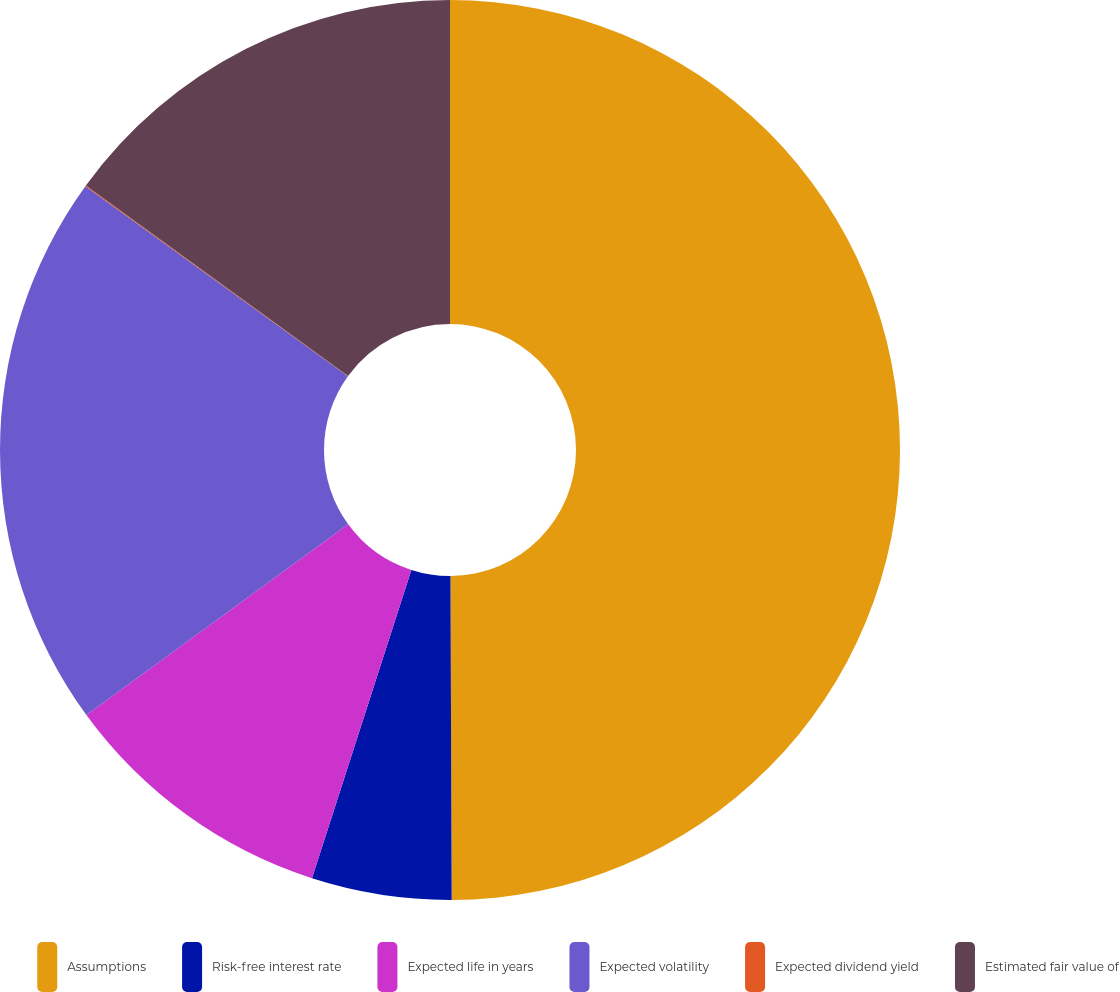Convert chart. <chart><loc_0><loc_0><loc_500><loc_500><pie_chart><fcel>Assumptions<fcel>Risk-free interest rate<fcel>Expected life in years<fcel>Expected volatility<fcel>Expected dividend yield<fcel>Estimated fair value of<nl><fcel>49.93%<fcel>5.02%<fcel>10.01%<fcel>19.99%<fcel>0.03%<fcel>15.0%<nl></chart> 